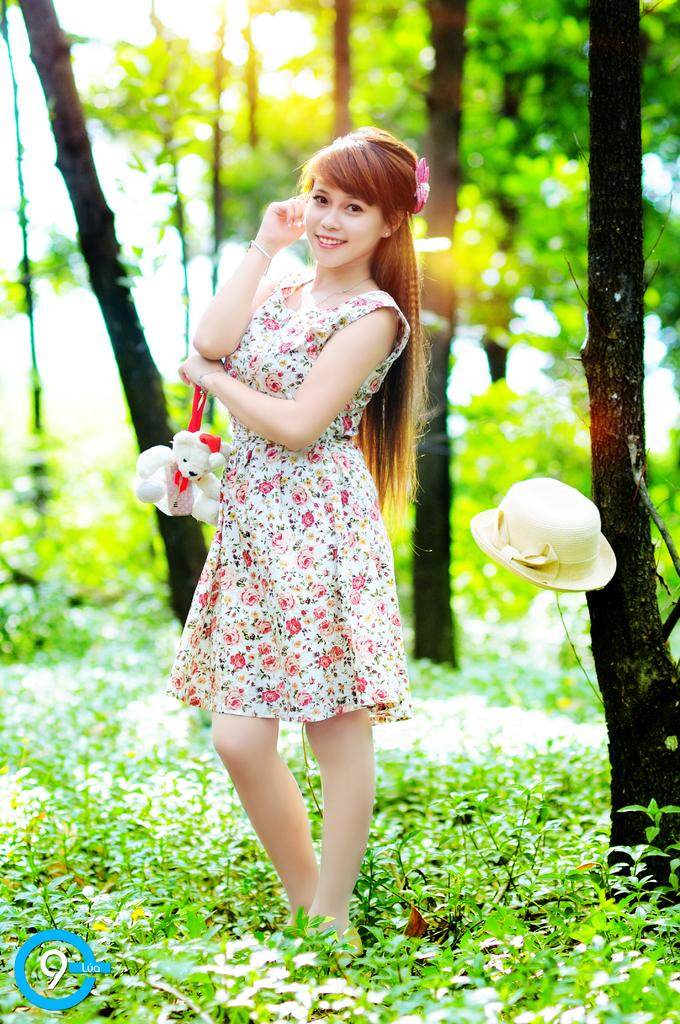Who is the main subject in the image? There is a girl standing in the image. What object is present in the image that is related to the girl? There is a doll in the image. What accessory is visible in the image? There is a hat in the image. What type of vegetation can be seen in the image? There are plants and trees visible in the image. What type of board is the girl using to perform tricks in the image? There is no board present in the image, and the girl is not performing any tricks. 